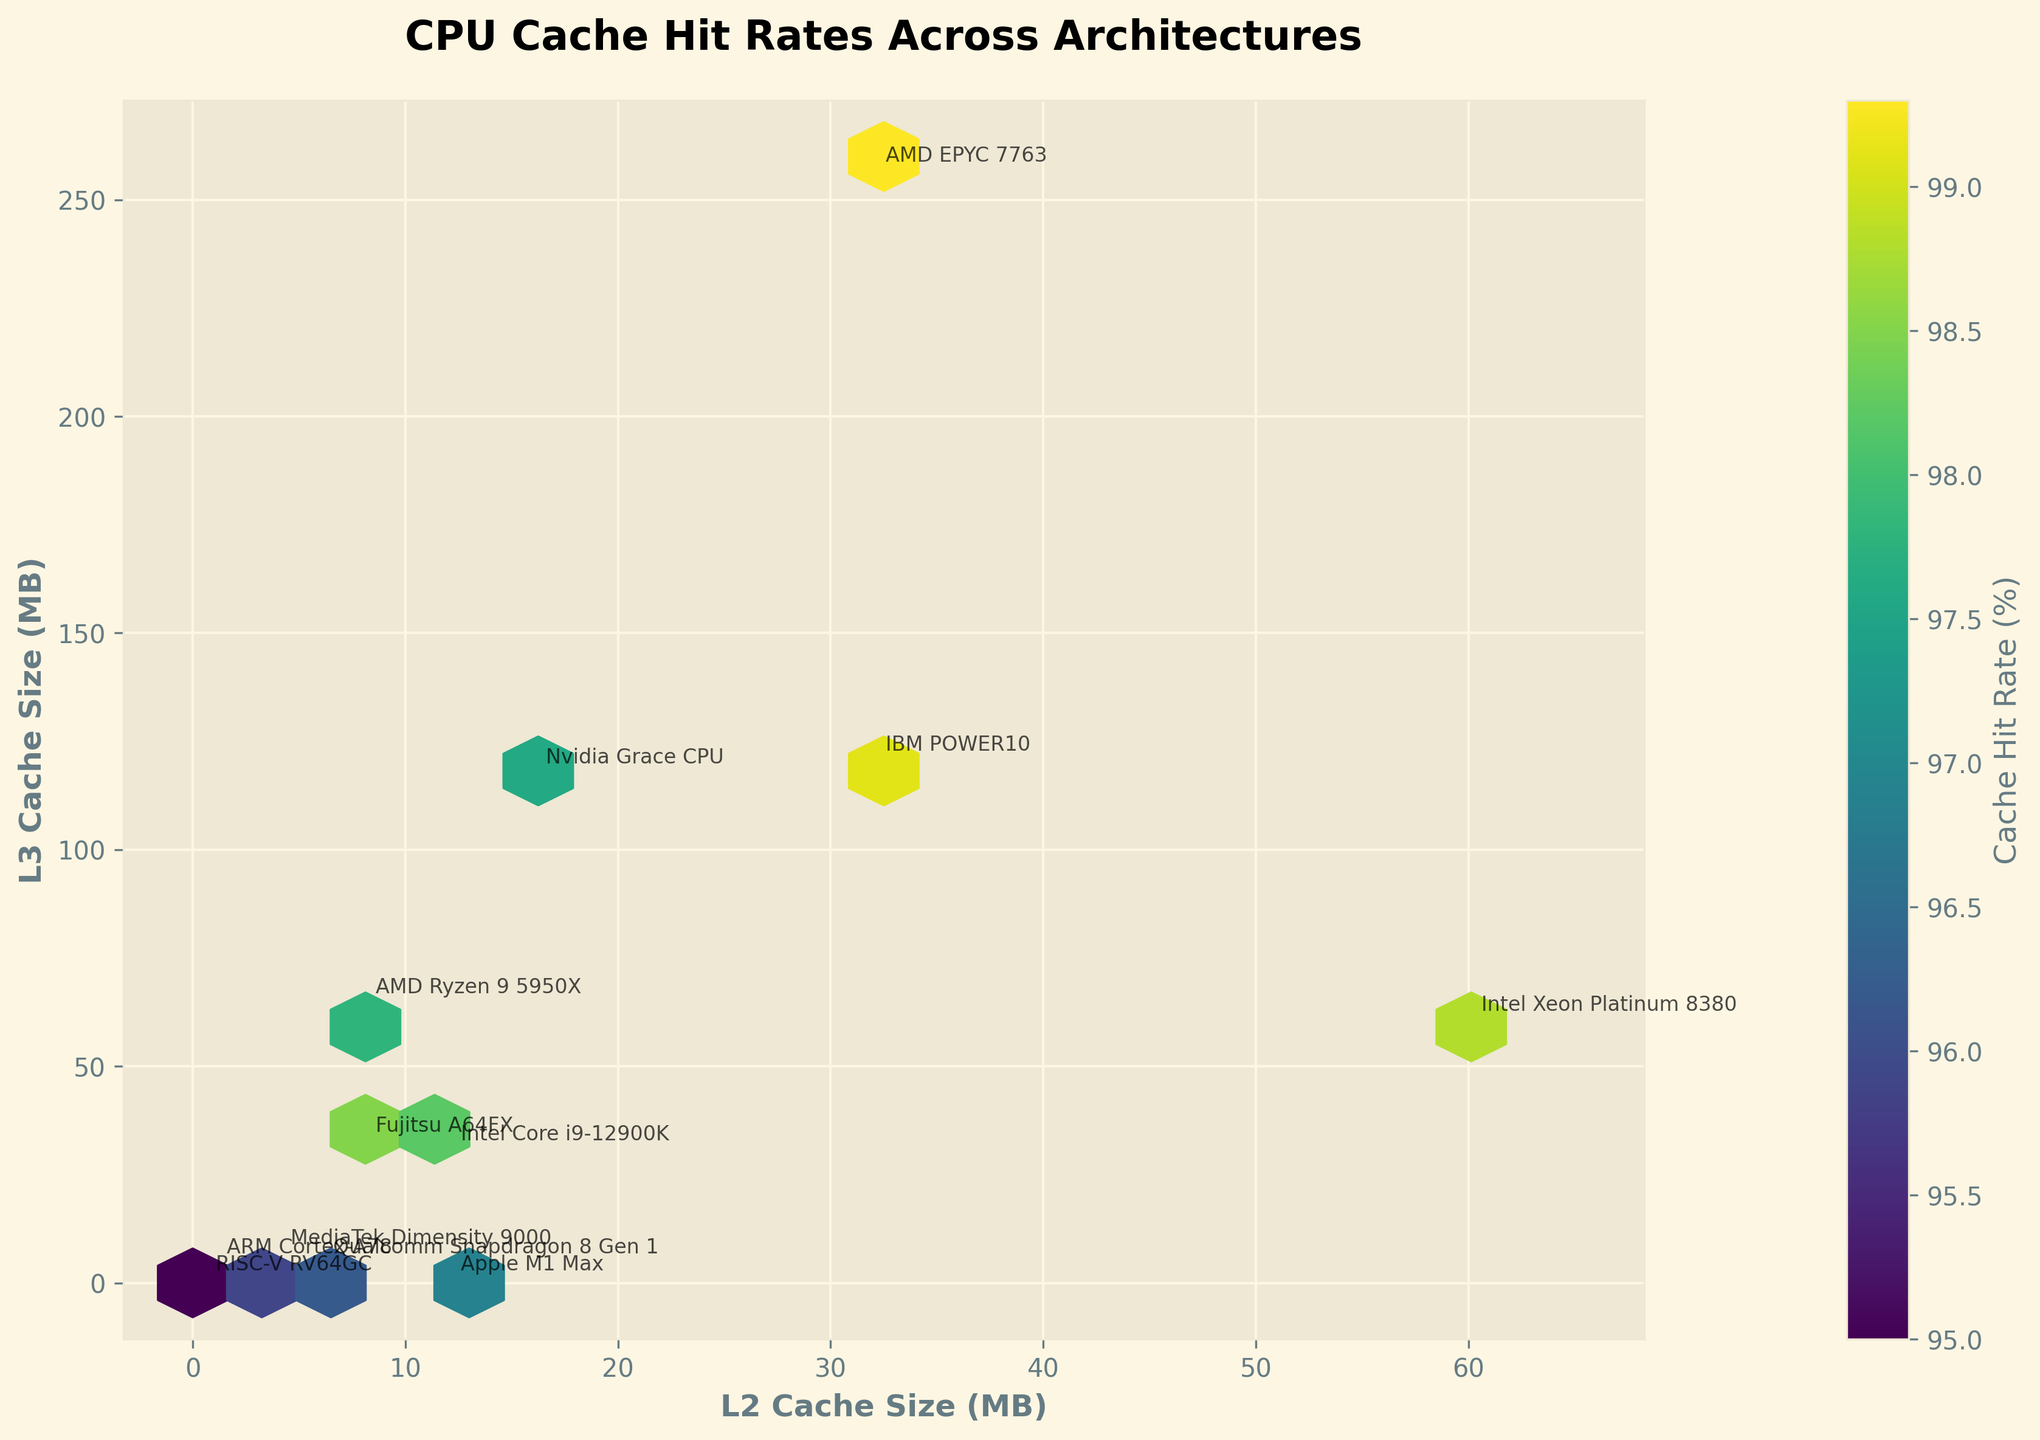What is the title of the plot? The title is located at the top of the plot in bold text. It reads "CPU Cache Hit Rates Across Architectures".
Answer: CPU Cache Hit Rates Across Architectures What are the x and y-axis labels? The x-axis label is "L2 Cache Size (MB)" and the y-axis label is "L3 Cache Size (MB)". This information is found near the bottom and left side of the plot, respectively.
Answer: L2 Cache Size (MB) and L3 Cache Size (MB) Which architecture has the highest cache hit rate? To find the architecture with the highest cache hit rate, identify the highest value in the color bar legend and look for corresponding points. Here, the highest cache hit rate is 99.3% for AMD EPYC 7763.
Answer: AMD EPYC 7763 How many data points have an L2 Cache Size of exactly 8 MB? Check the points on the x-axis where L2 Cache Size is 8 MB. There are two points, corresponding to "AMD Ryzen 9 5950X" and "Fujitsu A64FX".
Answer: 2 Which architectures do not have an L3 Cache? Identify architectures with L3 Cache Size of 0 MB on the y-axis. These are the "Apple M1 Max" and "RISC-V RV64GC".
Answer: Apple M1 Max and RISC-V RV64GC What is the range of L2 and L3 Cache Sizes represented in the plot? The range is shown through the extent of data points and the axis limits. L2 Cache Size ranges from 0 to 65 MB, and L3 Cache Size ranges from 0 to 260 MB.
Answer: 0-65 MB (L2) and 0-260 MB (L3) What color indicates a cache hit rate of about 97%? Check the color bar legend, which maps color gradients to cache hit rates. A yellow to light green color corresponds to a cache hit rate of roughly 97%.
Answer: Yellow to light green Which architectures have both L2 and L3 cache sizes greater than 30 MB? Check the points where both x-axis and y-axis values exceed 30 MB. The architectures meeting this requirement are "IBM POWER10" and "AMD EPYC 7763".
Answer: IBM POWER10 and AMD EPYC 7763 Is there a correlation between L2 and L3 Cache Sizes and cache hit rates? By observing the hexbin plot, we see higher hit rates (darker colors) scattered across different L2 and L3 sizes, indicating no clear linear correlation.
Answer: No clear correlation What is the architecture with the smallest L3 Cache Size and what is its cache hit rate? Identify the smallest L3 Cache Size (excluding 0) on the y-axis. "ARM Cortex-A78" has the smallest non-zero L3 Cache Size (4 MB) and a cache hit rate of 95.7%.
Answer: ARM Cortex-A78, 95.7% 